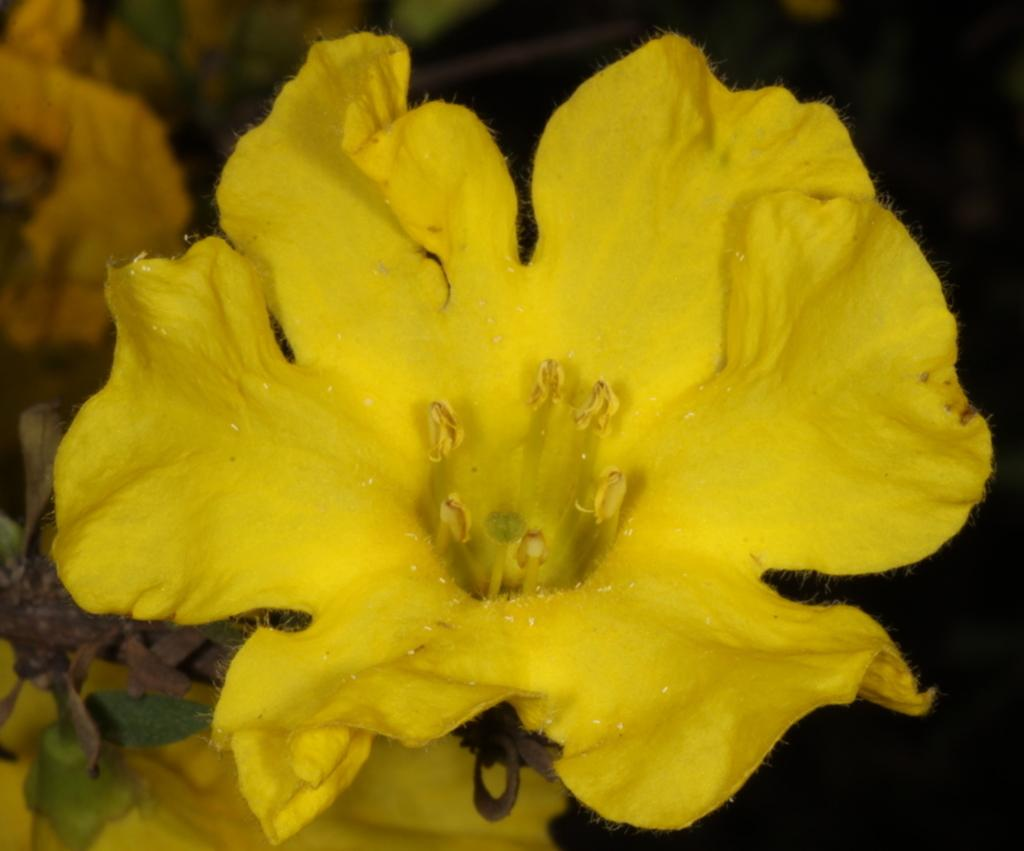What type of living organism is present in the image? There is a plant in the image. What color are the flowers on the plant? The plant has yellow flowers. What color are the leaves on the plant? The plant has green leaves. How would you describe the background of the image? The background of the image is dark in color. What type of zipper can be seen on the plant in the image? There is no zipper present on the plant in the image. How does the plant express anger in the image? Plants do not express emotions like anger; they are not capable of such expressions. 